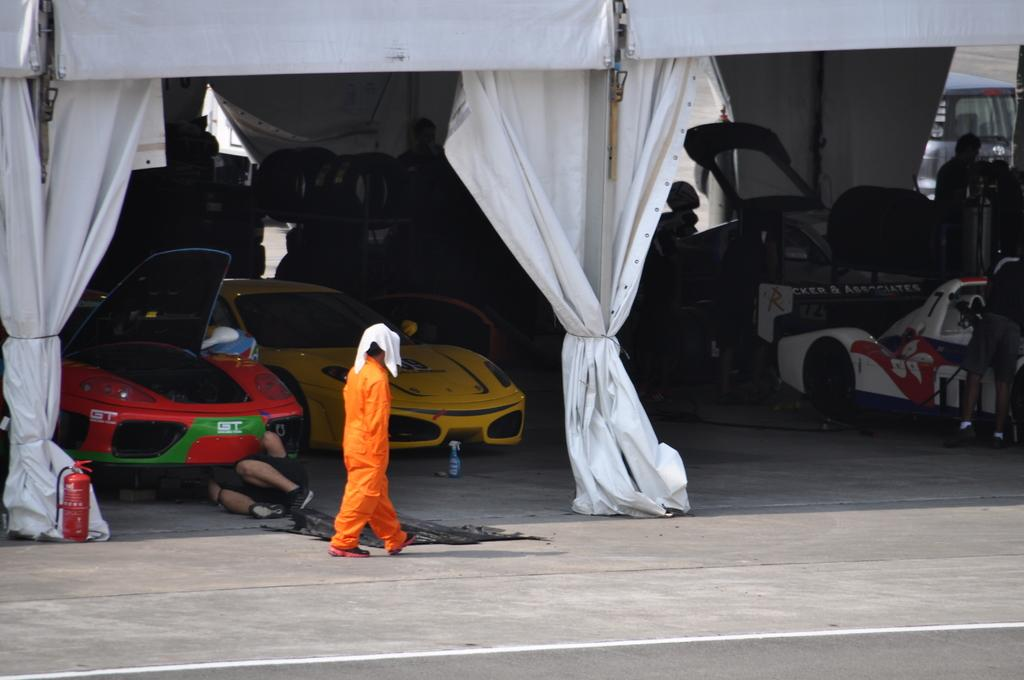What is the person in the image doing? There is a person walking on the road in the image. What can be seen in the background of the image? There are vehicles, people, a fire extinguisher, rods, and clothes visible in the background. Can you describe the vehicles in the background? The provided facts do not give specific details about the vehicles, so we cannot describe them. What type of marble is present in the image? There is no marble present in the image. Can you describe the middle of the road in the image? The provided facts do not give specific details about the middle of the road, so we cannot describe it. 